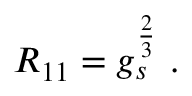<formula> <loc_0><loc_0><loc_500><loc_500>R _ { 1 1 } = g _ { s } ^ { \frac { 2 } { 3 } } \ .</formula> 